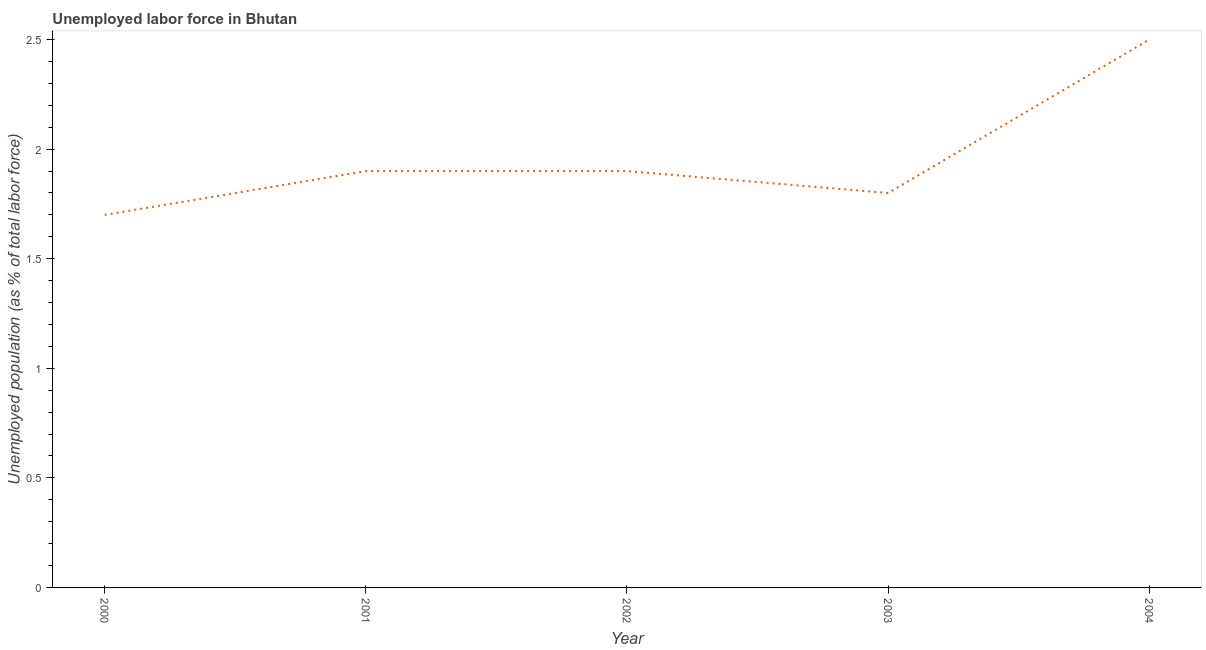What is the total unemployed population in 2001?
Your answer should be very brief. 1.9. Across all years, what is the minimum total unemployed population?
Your answer should be compact. 1.7. In which year was the total unemployed population minimum?
Your response must be concise. 2000. What is the sum of the total unemployed population?
Provide a succinct answer. 9.8. What is the difference between the total unemployed population in 2002 and 2004?
Your response must be concise. -0.6. What is the average total unemployed population per year?
Provide a short and direct response. 1.96. What is the median total unemployed population?
Make the answer very short. 1.9. In how many years, is the total unemployed population greater than 0.30000000000000004 %?
Your answer should be compact. 5. Do a majority of the years between 2000 and 2002 (inclusive) have total unemployed population greater than 1.1 %?
Offer a terse response. Yes. What is the ratio of the total unemployed population in 2001 to that in 2004?
Your answer should be very brief. 0.76. Is the total unemployed population in 2002 less than that in 2004?
Provide a succinct answer. Yes. What is the difference between the highest and the second highest total unemployed population?
Offer a terse response. 0.6. What is the difference between the highest and the lowest total unemployed population?
Your response must be concise. 0.8. Does the total unemployed population monotonically increase over the years?
Give a very brief answer. No. How many lines are there?
Ensure brevity in your answer.  1. What is the difference between two consecutive major ticks on the Y-axis?
Offer a very short reply. 0.5. Are the values on the major ticks of Y-axis written in scientific E-notation?
Make the answer very short. No. What is the title of the graph?
Your answer should be very brief. Unemployed labor force in Bhutan. What is the label or title of the Y-axis?
Make the answer very short. Unemployed population (as % of total labor force). What is the Unemployed population (as % of total labor force) of 2000?
Your response must be concise. 1.7. What is the Unemployed population (as % of total labor force) of 2001?
Offer a very short reply. 1.9. What is the Unemployed population (as % of total labor force) in 2002?
Provide a short and direct response. 1.9. What is the Unemployed population (as % of total labor force) in 2003?
Ensure brevity in your answer.  1.8. What is the difference between the Unemployed population (as % of total labor force) in 2000 and 2001?
Offer a very short reply. -0.2. What is the difference between the Unemployed population (as % of total labor force) in 2000 and 2003?
Your response must be concise. -0.1. What is the difference between the Unemployed population (as % of total labor force) in 2001 and 2002?
Your response must be concise. 0. What is the difference between the Unemployed population (as % of total labor force) in 2001 and 2003?
Ensure brevity in your answer.  0.1. What is the difference between the Unemployed population (as % of total labor force) in 2003 and 2004?
Your response must be concise. -0.7. What is the ratio of the Unemployed population (as % of total labor force) in 2000 to that in 2001?
Give a very brief answer. 0.9. What is the ratio of the Unemployed population (as % of total labor force) in 2000 to that in 2002?
Make the answer very short. 0.9. What is the ratio of the Unemployed population (as % of total labor force) in 2000 to that in 2003?
Make the answer very short. 0.94. What is the ratio of the Unemployed population (as % of total labor force) in 2000 to that in 2004?
Your answer should be very brief. 0.68. What is the ratio of the Unemployed population (as % of total labor force) in 2001 to that in 2002?
Provide a succinct answer. 1. What is the ratio of the Unemployed population (as % of total labor force) in 2001 to that in 2003?
Your response must be concise. 1.06. What is the ratio of the Unemployed population (as % of total labor force) in 2001 to that in 2004?
Your response must be concise. 0.76. What is the ratio of the Unemployed population (as % of total labor force) in 2002 to that in 2003?
Your answer should be compact. 1.06. What is the ratio of the Unemployed population (as % of total labor force) in 2002 to that in 2004?
Provide a short and direct response. 0.76. What is the ratio of the Unemployed population (as % of total labor force) in 2003 to that in 2004?
Keep it short and to the point. 0.72. 